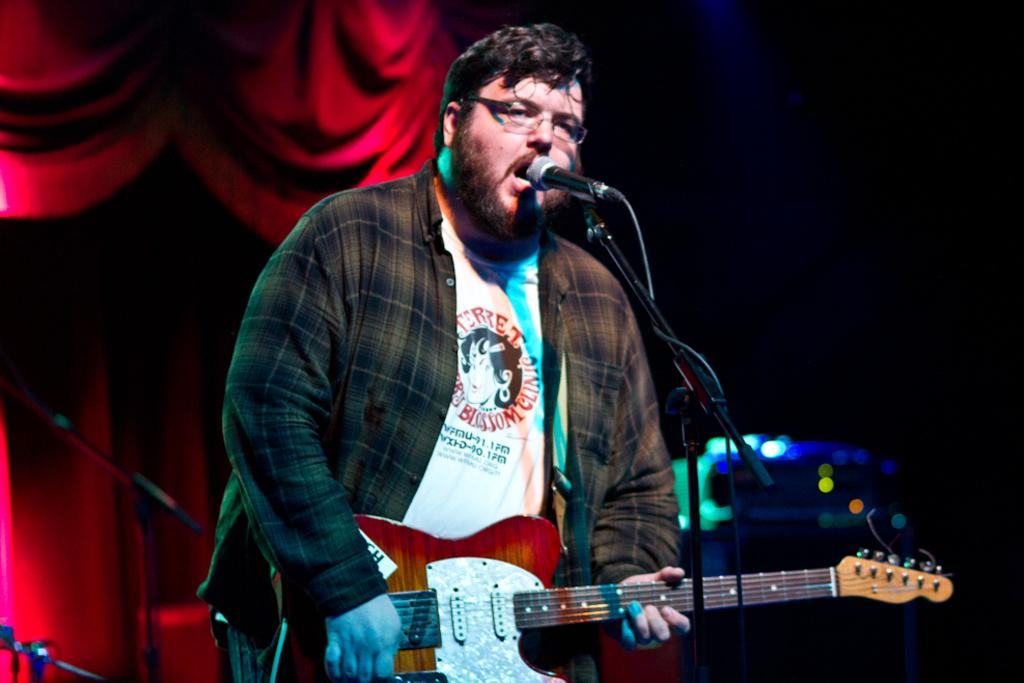What is the man in the image doing? The man is playing the guitar and singing. How is the man positioned in the image? The man is standing. What object is in front of the man? There is a microphone stand in front of the man. What can be seen in the background of the image? There are red curtains in the background of the image. What type of breakfast is the man eating in the image? There is no breakfast present in the image; the man is playing the guitar and singing. How many geese are visible in the image? There are no geese present in the image; the focus is on the man playing the guitar and singing. 